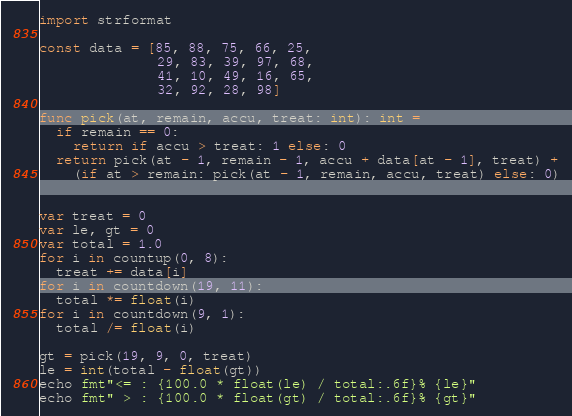Convert code to text. <code><loc_0><loc_0><loc_500><loc_500><_Nim_>import strformat

const data = [85, 88, 75, 66, 25,
              29, 83, 39, 97, 68,
              41, 10, 49, 16, 65,
              32, 92, 28, 98]

func pick(at, remain, accu, treat: int): int =
  if remain == 0:
    return if accu > treat: 1 else: 0
  return pick(at - 1, remain - 1, accu + data[at - 1], treat) +
    (if at > remain: pick(at - 1, remain, accu, treat) else: 0)


var treat = 0
var le, gt = 0
var total = 1.0
for i in countup(0, 8):
  treat += data[i]
for i in countdown(19, 11):
  total *= float(i)
for i in countdown(9, 1):
  total /= float(i)

gt = pick(19, 9, 0, treat)
le = int(total - float(gt))
echo fmt"<= : {100.0 * float(le) / total:.6f}% {le}"
echo fmt" > : {100.0 * float(gt) / total:.6f}% {gt}"
</code> 